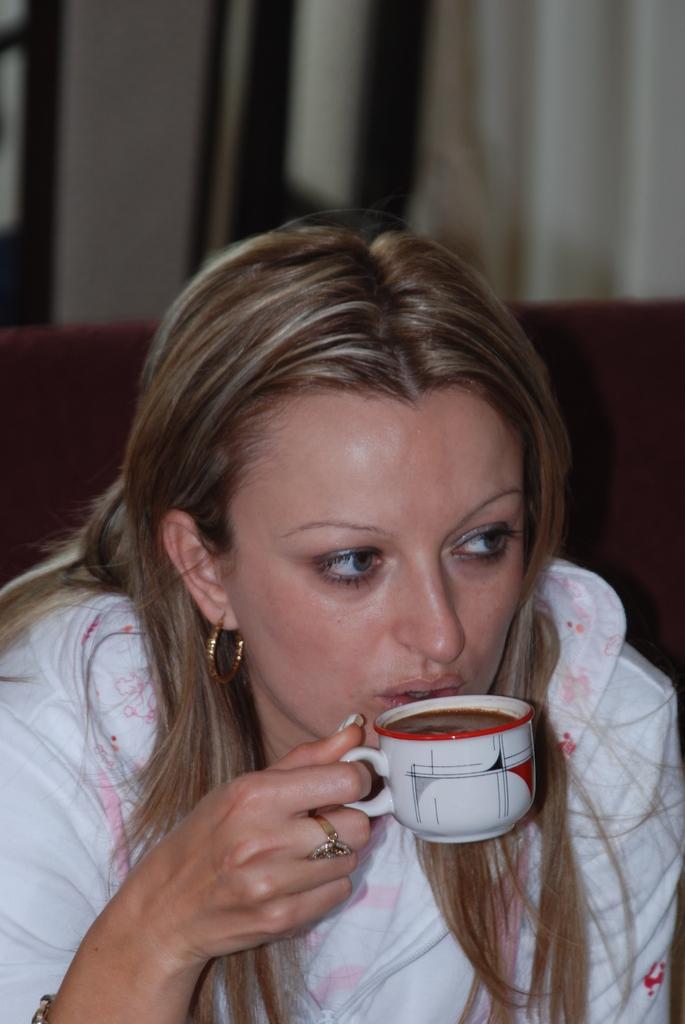Describe this image in one or two sentences. In the center of the image there is a lady, she is holding a cup in her hand. In the background there is a curtain. 